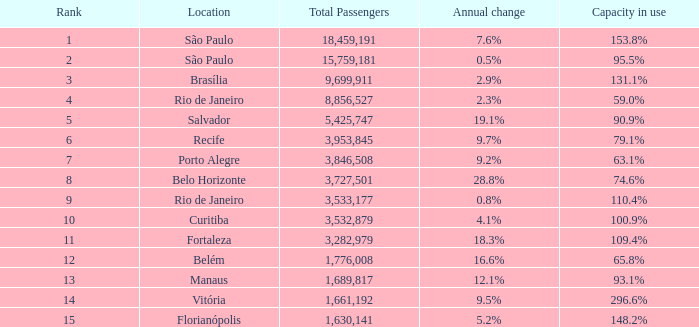What is the total number of passengers when the yearly change is None. 